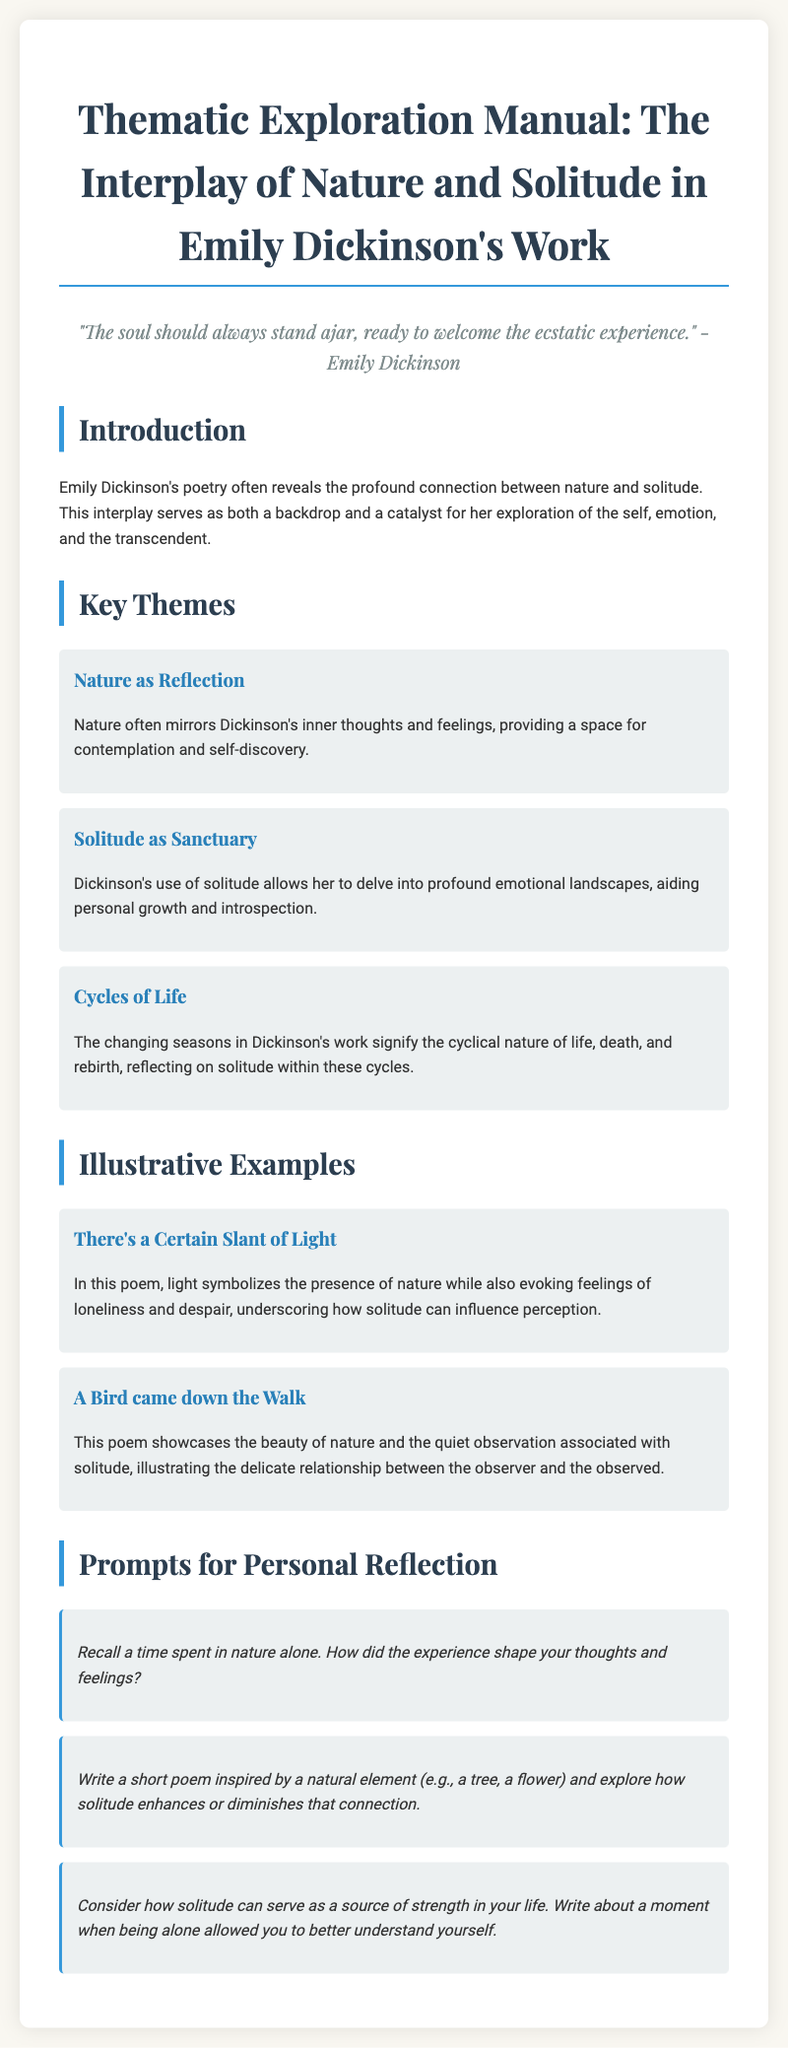What are the key themes explored in Dickinson's work? The key themes are listed in the document, highlighting the relationship between nature and solitude.
Answer: Nature as Reflection, Solitude as Sanctuary, Cycles of Life Which poem is associated with the symbol of light? This poem is mentioned in the illustrative examples, showcasing how light symbolizes nature and loneliness.
Answer: There's a Certain Slant of Light How many prompts for personal reflection are provided? The document lists the number of prompts available for personal reflection.
Answer: Three What is the purpose of solitude according to Dickinson's work? The manual describes solitude as a means for delving into emotional landscapes and promoting introspection.
Answer: Sanctuary What might you reflect on according to the first personal reflection prompt? The prompt invites reflection on personal experiences in nature alone and its impact on thoughts and feelings.
Answer: Experience in nature alone What is the significance of changing seasons in Dickinson's poetry? The document explains that changing seasons represent life cycles and the solitude within these cycles.
Answer: Cyclical nature of life What is the quote attributed to Emily Dickinson found in the document? The quote reflects Dickinson's belief about the openness of the soul to experiences.
Answer: "The soul should always stand ajar, ready to welcome the ecstatic experience." 